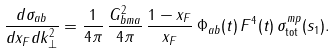Convert formula to latex. <formula><loc_0><loc_0><loc_500><loc_500>\frac { d \sigma _ { a b } } { d x _ { F } d k _ { \bot } ^ { 2 } } = \frac { 1 } { 4 \pi } \, \frac { G ^ { 2 } _ { b m a } } { 4 \pi } \, \frac { 1 - x _ { F } } { x _ { F } } \, \Phi _ { a b } ( t ) \, F ^ { 4 } ( t ) \, \sigma _ { \text {tot} } ^ { m p } ( s _ { 1 } ) .</formula> 